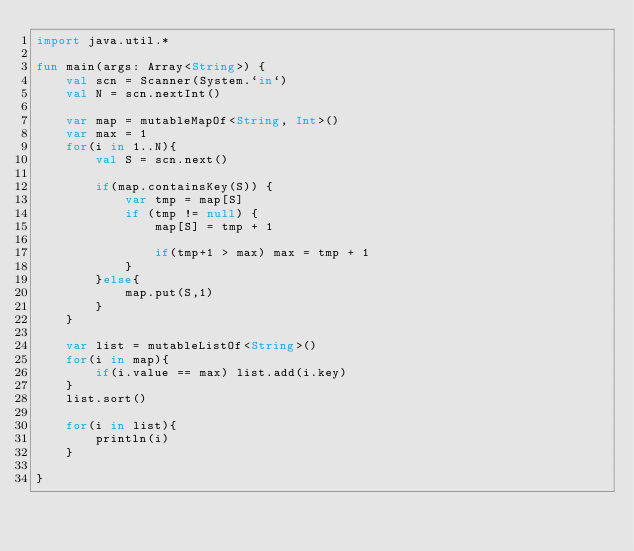<code> <loc_0><loc_0><loc_500><loc_500><_Kotlin_>import java.util.*

fun main(args: Array<String>) {
    val scn = Scanner(System.`in`)
    val N = scn.nextInt()

    var map = mutableMapOf<String, Int>()
    var max = 1
    for(i in 1..N){
        val S = scn.next()

        if(map.containsKey(S)) {
            var tmp = map[S]
            if (tmp != null) {
                map[S] = tmp + 1

                if(tmp+1 > max) max = tmp + 1
            }
        }else{
            map.put(S,1)
        }
    }

    var list = mutableListOf<String>()
    for(i in map){
        if(i.value == max) list.add(i.key)
    }
    list.sort()

    for(i in list){
        println(i)
    }

}</code> 